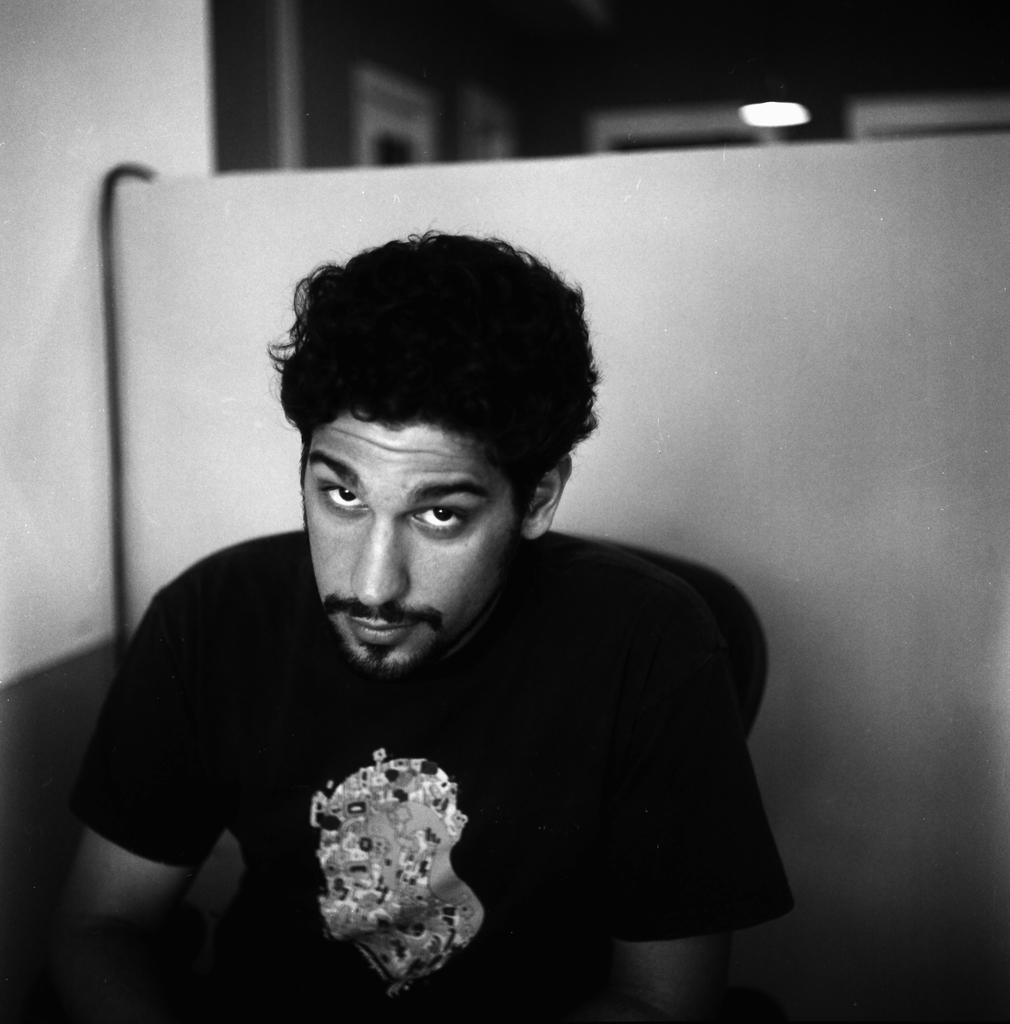What is the main subject of the image? There is a person in the image. What is the color scheme of the image? The image is in black and white. Can you describe the lighting in the image? There is a light source visible in the background of the image. What type of canvas is the person painting on in the image? There is no canvas or painting activity present in the image. How does the person feel about their actions in the image? The image does not convey any emotions or feelings, so we cannot determine how the person feels about their actions. 